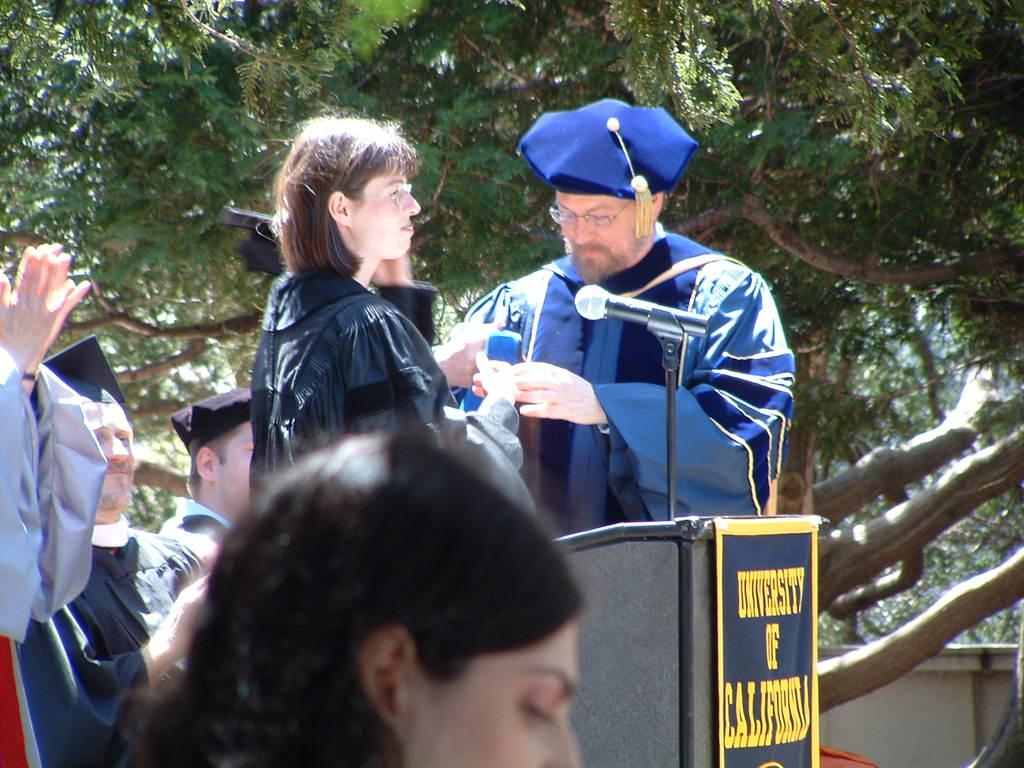How many people are in the image? There are a few people in the image. What can be seen near the people in the image? There is a podium, a board with text, and a microphone in the image. What type of vegetation is visible in the image? There are a few trees in the image. What type of structure is present in the image? There is a wall in the image. What time is displayed on the clock in the image? There is no clock present in the image. What type of food is the cook preparing in the image? There is no cook or food preparation visible in the image. 